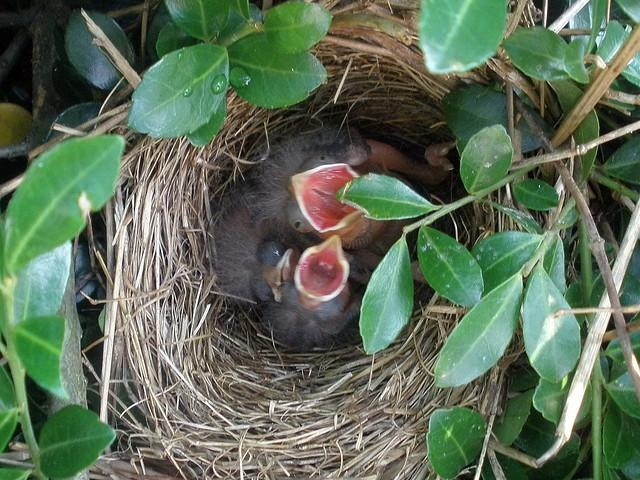Why are their mouths open? hungry 